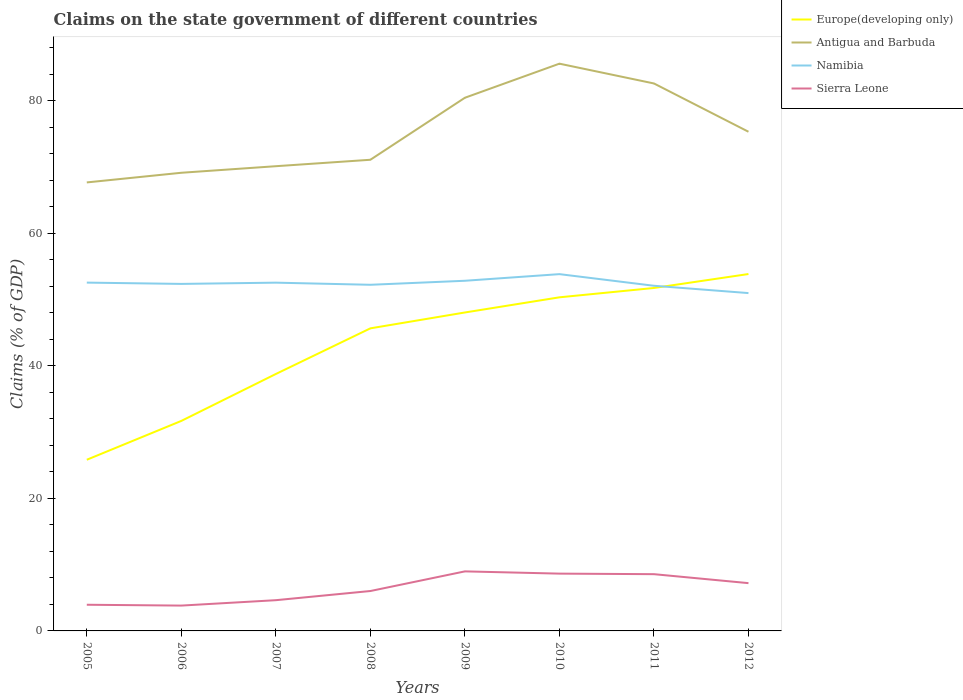Does the line corresponding to Europe(developing only) intersect with the line corresponding to Sierra Leone?
Keep it short and to the point. No. Across all years, what is the maximum percentage of GDP claimed on the state government in Europe(developing only)?
Your answer should be very brief. 25.82. In which year was the percentage of GDP claimed on the state government in Namibia maximum?
Provide a short and direct response. 2012. What is the total percentage of GDP claimed on the state government in Sierra Leone in the graph?
Ensure brevity in your answer.  -4.35. What is the difference between the highest and the second highest percentage of GDP claimed on the state government in Namibia?
Provide a short and direct response. 2.86. Is the percentage of GDP claimed on the state government in Sierra Leone strictly greater than the percentage of GDP claimed on the state government in Namibia over the years?
Your response must be concise. Yes. What is the difference between two consecutive major ticks on the Y-axis?
Give a very brief answer. 20. Are the values on the major ticks of Y-axis written in scientific E-notation?
Your response must be concise. No. Does the graph contain any zero values?
Your answer should be compact. No. Does the graph contain grids?
Make the answer very short. No. How many legend labels are there?
Provide a succinct answer. 4. What is the title of the graph?
Make the answer very short. Claims on the state government of different countries. Does "Hungary" appear as one of the legend labels in the graph?
Ensure brevity in your answer.  No. What is the label or title of the Y-axis?
Offer a terse response. Claims (% of GDP). What is the Claims (% of GDP) of Europe(developing only) in 2005?
Provide a succinct answer. 25.82. What is the Claims (% of GDP) in Antigua and Barbuda in 2005?
Your response must be concise. 67.66. What is the Claims (% of GDP) of Namibia in 2005?
Your answer should be compact. 52.55. What is the Claims (% of GDP) of Sierra Leone in 2005?
Provide a succinct answer. 3.95. What is the Claims (% of GDP) in Europe(developing only) in 2006?
Offer a terse response. 31.68. What is the Claims (% of GDP) in Antigua and Barbuda in 2006?
Make the answer very short. 69.12. What is the Claims (% of GDP) in Namibia in 2006?
Provide a succinct answer. 52.35. What is the Claims (% of GDP) in Sierra Leone in 2006?
Provide a succinct answer. 3.82. What is the Claims (% of GDP) of Europe(developing only) in 2007?
Ensure brevity in your answer.  38.76. What is the Claims (% of GDP) in Antigua and Barbuda in 2007?
Provide a succinct answer. 70.11. What is the Claims (% of GDP) in Namibia in 2007?
Make the answer very short. 52.54. What is the Claims (% of GDP) in Sierra Leone in 2007?
Make the answer very short. 4.64. What is the Claims (% of GDP) of Europe(developing only) in 2008?
Make the answer very short. 45.65. What is the Claims (% of GDP) of Antigua and Barbuda in 2008?
Your answer should be very brief. 71.08. What is the Claims (% of GDP) of Namibia in 2008?
Offer a very short reply. 52.22. What is the Claims (% of GDP) of Sierra Leone in 2008?
Provide a succinct answer. 6.02. What is the Claims (% of GDP) in Europe(developing only) in 2009?
Your answer should be compact. 48.04. What is the Claims (% of GDP) in Antigua and Barbuda in 2009?
Make the answer very short. 80.43. What is the Claims (% of GDP) of Namibia in 2009?
Offer a very short reply. 52.82. What is the Claims (% of GDP) in Sierra Leone in 2009?
Provide a succinct answer. 8.98. What is the Claims (% of GDP) in Europe(developing only) in 2010?
Offer a terse response. 50.33. What is the Claims (% of GDP) of Antigua and Barbuda in 2010?
Provide a short and direct response. 85.58. What is the Claims (% of GDP) in Namibia in 2010?
Provide a short and direct response. 53.82. What is the Claims (% of GDP) of Sierra Leone in 2010?
Your answer should be very brief. 8.64. What is the Claims (% of GDP) of Europe(developing only) in 2011?
Give a very brief answer. 51.74. What is the Claims (% of GDP) in Antigua and Barbuda in 2011?
Your answer should be compact. 82.59. What is the Claims (% of GDP) in Namibia in 2011?
Give a very brief answer. 52.07. What is the Claims (% of GDP) in Sierra Leone in 2011?
Give a very brief answer. 8.56. What is the Claims (% of GDP) of Europe(developing only) in 2012?
Give a very brief answer. 53.84. What is the Claims (% of GDP) of Antigua and Barbuda in 2012?
Your response must be concise. 75.3. What is the Claims (% of GDP) of Namibia in 2012?
Offer a very short reply. 50.97. What is the Claims (% of GDP) of Sierra Leone in 2012?
Offer a terse response. 7.21. Across all years, what is the maximum Claims (% of GDP) of Europe(developing only)?
Offer a terse response. 53.84. Across all years, what is the maximum Claims (% of GDP) in Antigua and Barbuda?
Your answer should be compact. 85.58. Across all years, what is the maximum Claims (% of GDP) of Namibia?
Your response must be concise. 53.82. Across all years, what is the maximum Claims (% of GDP) in Sierra Leone?
Offer a very short reply. 8.98. Across all years, what is the minimum Claims (% of GDP) of Europe(developing only)?
Your response must be concise. 25.82. Across all years, what is the minimum Claims (% of GDP) in Antigua and Barbuda?
Give a very brief answer. 67.66. Across all years, what is the minimum Claims (% of GDP) in Namibia?
Provide a succinct answer. 50.97. Across all years, what is the minimum Claims (% of GDP) of Sierra Leone?
Ensure brevity in your answer.  3.82. What is the total Claims (% of GDP) in Europe(developing only) in the graph?
Provide a short and direct response. 345.86. What is the total Claims (% of GDP) of Antigua and Barbuda in the graph?
Make the answer very short. 601.87. What is the total Claims (% of GDP) of Namibia in the graph?
Provide a succinct answer. 419.34. What is the total Claims (% of GDP) in Sierra Leone in the graph?
Offer a very short reply. 51.82. What is the difference between the Claims (% of GDP) of Europe(developing only) in 2005 and that in 2006?
Offer a very short reply. -5.86. What is the difference between the Claims (% of GDP) of Antigua and Barbuda in 2005 and that in 2006?
Offer a terse response. -1.46. What is the difference between the Claims (% of GDP) of Namibia in 2005 and that in 2006?
Keep it short and to the point. 0.2. What is the difference between the Claims (% of GDP) of Sierra Leone in 2005 and that in 2006?
Your response must be concise. 0.13. What is the difference between the Claims (% of GDP) in Europe(developing only) in 2005 and that in 2007?
Keep it short and to the point. -12.94. What is the difference between the Claims (% of GDP) of Antigua and Barbuda in 2005 and that in 2007?
Give a very brief answer. -2.45. What is the difference between the Claims (% of GDP) in Namibia in 2005 and that in 2007?
Keep it short and to the point. 0.01. What is the difference between the Claims (% of GDP) in Sierra Leone in 2005 and that in 2007?
Provide a short and direct response. -0.69. What is the difference between the Claims (% of GDP) of Europe(developing only) in 2005 and that in 2008?
Your response must be concise. -19.82. What is the difference between the Claims (% of GDP) in Antigua and Barbuda in 2005 and that in 2008?
Make the answer very short. -3.42. What is the difference between the Claims (% of GDP) of Namibia in 2005 and that in 2008?
Give a very brief answer. 0.33. What is the difference between the Claims (% of GDP) of Sierra Leone in 2005 and that in 2008?
Your response must be concise. -2.07. What is the difference between the Claims (% of GDP) of Europe(developing only) in 2005 and that in 2009?
Provide a short and direct response. -22.22. What is the difference between the Claims (% of GDP) in Antigua and Barbuda in 2005 and that in 2009?
Your answer should be very brief. -12.77. What is the difference between the Claims (% of GDP) in Namibia in 2005 and that in 2009?
Provide a succinct answer. -0.28. What is the difference between the Claims (% of GDP) in Sierra Leone in 2005 and that in 2009?
Provide a succinct answer. -5.04. What is the difference between the Claims (% of GDP) of Europe(developing only) in 2005 and that in 2010?
Offer a terse response. -24.5. What is the difference between the Claims (% of GDP) in Antigua and Barbuda in 2005 and that in 2010?
Offer a very short reply. -17.91. What is the difference between the Claims (% of GDP) in Namibia in 2005 and that in 2010?
Your response must be concise. -1.28. What is the difference between the Claims (% of GDP) of Sierra Leone in 2005 and that in 2010?
Provide a short and direct response. -4.7. What is the difference between the Claims (% of GDP) of Europe(developing only) in 2005 and that in 2011?
Provide a short and direct response. -25.91. What is the difference between the Claims (% of GDP) in Antigua and Barbuda in 2005 and that in 2011?
Offer a very short reply. -14.93. What is the difference between the Claims (% of GDP) in Namibia in 2005 and that in 2011?
Offer a very short reply. 0.48. What is the difference between the Claims (% of GDP) of Sierra Leone in 2005 and that in 2011?
Give a very brief answer. -4.61. What is the difference between the Claims (% of GDP) of Europe(developing only) in 2005 and that in 2012?
Ensure brevity in your answer.  -28.02. What is the difference between the Claims (% of GDP) of Antigua and Barbuda in 2005 and that in 2012?
Keep it short and to the point. -7.64. What is the difference between the Claims (% of GDP) in Namibia in 2005 and that in 2012?
Provide a short and direct response. 1.58. What is the difference between the Claims (% of GDP) of Sierra Leone in 2005 and that in 2012?
Offer a very short reply. -3.26. What is the difference between the Claims (% of GDP) in Europe(developing only) in 2006 and that in 2007?
Provide a succinct answer. -7.08. What is the difference between the Claims (% of GDP) in Antigua and Barbuda in 2006 and that in 2007?
Offer a terse response. -0.99. What is the difference between the Claims (% of GDP) of Namibia in 2006 and that in 2007?
Provide a short and direct response. -0.19. What is the difference between the Claims (% of GDP) in Sierra Leone in 2006 and that in 2007?
Give a very brief answer. -0.81. What is the difference between the Claims (% of GDP) in Europe(developing only) in 2006 and that in 2008?
Give a very brief answer. -13.96. What is the difference between the Claims (% of GDP) of Antigua and Barbuda in 2006 and that in 2008?
Give a very brief answer. -1.96. What is the difference between the Claims (% of GDP) in Namibia in 2006 and that in 2008?
Offer a very short reply. 0.13. What is the difference between the Claims (% of GDP) in Sierra Leone in 2006 and that in 2008?
Ensure brevity in your answer.  -2.2. What is the difference between the Claims (% of GDP) in Europe(developing only) in 2006 and that in 2009?
Make the answer very short. -16.36. What is the difference between the Claims (% of GDP) of Antigua and Barbuda in 2006 and that in 2009?
Give a very brief answer. -11.32. What is the difference between the Claims (% of GDP) in Namibia in 2006 and that in 2009?
Ensure brevity in your answer.  -0.47. What is the difference between the Claims (% of GDP) in Sierra Leone in 2006 and that in 2009?
Ensure brevity in your answer.  -5.16. What is the difference between the Claims (% of GDP) in Europe(developing only) in 2006 and that in 2010?
Provide a succinct answer. -18.65. What is the difference between the Claims (% of GDP) of Antigua and Barbuda in 2006 and that in 2010?
Make the answer very short. -16.46. What is the difference between the Claims (% of GDP) in Namibia in 2006 and that in 2010?
Keep it short and to the point. -1.47. What is the difference between the Claims (% of GDP) in Sierra Leone in 2006 and that in 2010?
Offer a terse response. -4.82. What is the difference between the Claims (% of GDP) in Europe(developing only) in 2006 and that in 2011?
Your response must be concise. -20.06. What is the difference between the Claims (% of GDP) of Antigua and Barbuda in 2006 and that in 2011?
Keep it short and to the point. -13.47. What is the difference between the Claims (% of GDP) in Namibia in 2006 and that in 2011?
Provide a short and direct response. 0.28. What is the difference between the Claims (% of GDP) of Sierra Leone in 2006 and that in 2011?
Keep it short and to the point. -4.74. What is the difference between the Claims (% of GDP) of Europe(developing only) in 2006 and that in 2012?
Offer a very short reply. -22.16. What is the difference between the Claims (% of GDP) of Antigua and Barbuda in 2006 and that in 2012?
Your answer should be compact. -6.19. What is the difference between the Claims (% of GDP) in Namibia in 2006 and that in 2012?
Ensure brevity in your answer.  1.38. What is the difference between the Claims (% of GDP) in Sierra Leone in 2006 and that in 2012?
Provide a short and direct response. -3.39. What is the difference between the Claims (% of GDP) of Europe(developing only) in 2007 and that in 2008?
Ensure brevity in your answer.  -6.89. What is the difference between the Claims (% of GDP) of Antigua and Barbuda in 2007 and that in 2008?
Your answer should be very brief. -0.97. What is the difference between the Claims (% of GDP) of Namibia in 2007 and that in 2008?
Offer a terse response. 0.32. What is the difference between the Claims (% of GDP) in Sierra Leone in 2007 and that in 2008?
Offer a very short reply. -1.38. What is the difference between the Claims (% of GDP) in Europe(developing only) in 2007 and that in 2009?
Ensure brevity in your answer.  -9.28. What is the difference between the Claims (% of GDP) in Antigua and Barbuda in 2007 and that in 2009?
Make the answer very short. -10.33. What is the difference between the Claims (% of GDP) in Namibia in 2007 and that in 2009?
Provide a short and direct response. -0.28. What is the difference between the Claims (% of GDP) in Sierra Leone in 2007 and that in 2009?
Your response must be concise. -4.35. What is the difference between the Claims (% of GDP) of Europe(developing only) in 2007 and that in 2010?
Provide a succinct answer. -11.57. What is the difference between the Claims (% of GDP) in Antigua and Barbuda in 2007 and that in 2010?
Your response must be concise. -15.47. What is the difference between the Claims (% of GDP) of Namibia in 2007 and that in 2010?
Your answer should be very brief. -1.28. What is the difference between the Claims (% of GDP) in Sierra Leone in 2007 and that in 2010?
Make the answer very short. -4.01. What is the difference between the Claims (% of GDP) of Europe(developing only) in 2007 and that in 2011?
Give a very brief answer. -12.98. What is the difference between the Claims (% of GDP) in Antigua and Barbuda in 2007 and that in 2011?
Offer a very short reply. -12.48. What is the difference between the Claims (% of GDP) in Namibia in 2007 and that in 2011?
Ensure brevity in your answer.  0.47. What is the difference between the Claims (% of GDP) of Sierra Leone in 2007 and that in 2011?
Provide a succinct answer. -3.92. What is the difference between the Claims (% of GDP) of Europe(developing only) in 2007 and that in 2012?
Ensure brevity in your answer.  -15.08. What is the difference between the Claims (% of GDP) of Antigua and Barbuda in 2007 and that in 2012?
Keep it short and to the point. -5.2. What is the difference between the Claims (% of GDP) in Namibia in 2007 and that in 2012?
Keep it short and to the point. 1.57. What is the difference between the Claims (% of GDP) in Sierra Leone in 2007 and that in 2012?
Ensure brevity in your answer.  -2.57. What is the difference between the Claims (% of GDP) in Europe(developing only) in 2008 and that in 2009?
Give a very brief answer. -2.39. What is the difference between the Claims (% of GDP) of Antigua and Barbuda in 2008 and that in 2009?
Keep it short and to the point. -9.35. What is the difference between the Claims (% of GDP) in Namibia in 2008 and that in 2009?
Make the answer very short. -0.6. What is the difference between the Claims (% of GDP) of Sierra Leone in 2008 and that in 2009?
Provide a succinct answer. -2.96. What is the difference between the Claims (% of GDP) in Europe(developing only) in 2008 and that in 2010?
Give a very brief answer. -4.68. What is the difference between the Claims (% of GDP) of Antigua and Barbuda in 2008 and that in 2010?
Offer a terse response. -14.5. What is the difference between the Claims (% of GDP) in Namibia in 2008 and that in 2010?
Your answer should be very brief. -1.6. What is the difference between the Claims (% of GDP) of Sierra Leone in 2008 and that in 2010?
Your response must be concise. -2.62. What is the difference between the Claims (% of GDP) of Europe(developing only) in 2008 and that in 2011?
Provide a succinct answer. -6.09. What is the difference between the Claims (% of GDP) of Antigua and Barbuda in 2008 and that in 2011?
Provide a succinct answer. -11.51. What is the difference between the Claims (% of GDP) in Namibia in 2008 and that in 2011?
Make the answer very short. 0.15. What is the difference between the Claims (% of GDP) of Sierra Leone in 2008 and that in 2011?
Provide a succinct answer. -2.54. What is the difference between the Claims (% of GDP) in Europe(developing only) in 2008 and that in 2012?
Your answer should be very brief. -8.19. What is the difference between the Claims (% of GDP) of Antigua and Barbuda in 2008 and that in 2012?
Your answer should be compact. -4.23. What is the difference between the Claims (% of GDP) in Namibia in 2008 and that in 2012?
Offer a very short reply. 1.25. What is the difference between the Claims (% of GDP) in Sierra Leone in 2008 and that in 2012?
Provide a short and direct response. -1.19. What is the difference between the Claims (% of GDP) of Europe(developing only) in 2009 and that in 2010?
Provide a short and direct response. -2.29. What is the difference between the Claims (% of GDP) of Antigua and Barbuda in 2009 and that in 2010?
Keep it short and to the point. -5.14. What is the difference between the Claims (% of GDP) in Namibia in 2009 and that in 2010?
Your response must be concise. -1. What is the difference between the Claims (% of GDP) in Sierra Leone in 2009 and that in 2010?
Provide a succinct answer. 0.34. What is the difference between the Claims (% of GDP) of Europe(developing only) in 2009 and that in 2011?
Provide a succinct answer. -3.7. What is the difference between the Claims (% of GDP) in Antigua and Barbuda in 2009 and that in 2011?
Provide a succinct answer. -2.16. What is the difference between the Claims (% of GDP) of Namibia in 2009 and that in 2011?
Your answer should be compact. 0.75. What is the difference between the Claims (% of GDP) in Sierra Leone in 2009 and that in 2011?
Provide a succinct answer. 0.42. What is the difference between the Claims (% of GDP) in Europe(developing only) in 2009 and that in 2012?
Provide a short and direct response. -5.8. What is the difference between the Claims (% of GDP) in Antigua and Barbuda in 2009 and that in 2012?
Offer a very short reply. 5.13. What is the difference between the Claims (% of GDP) in Namibia in 2009 and that in 2012?
Provide a short and direct response. 1.86. What is the difference between the Claims (% of GDP) of Sierra Leone in 2009 and that in 2012?
Make the answer very short. 1.77. What is the difference between the Claims (% of GDP) of Europe(developing only) in 2010 and that in 2011?
Offer a very short reply. -1.41. What is the difference between the Claims (% of GDP) in Antigua and Barbuda in 2010 and that in 2011?
Your answer should be very brief. 2.99. What is the difference between the Claims (% of GDP) of Namibia in 2010 and that in 2011?
Make the answer very short. 1.75. What is the difference between the Claims (% of GDP) of Sierra Leone in 2010 and that in 2011?
Keep it short and to the point. 0.08. What is the difference between the Claims (% of GDP) in Europe(developing only) in 2010 and that in 2012?
Offer a very short reply. -3.51. What is the difference between the Claims (% of GDP) of Antigua and Barbuda in 2010 and that in 2012?
Provide a succinct answer. 10.27. What is the difference between the Claims (% of GDP) in Namibia in 2010 and that in 2012?
Offer a terse response. 2.86. What is the difference between the Claims (% of GDP) of Sierra Leone in 2010 and that in 2012?
Your answer should be compact. 1.44. What is the difference between the Claims (% of GDP) in Europe(developing only) in 2011 and that in 2012?
Provide a short and direct response. -2.1. What is the difference between the Claims (% of GDP) in Antigua and Barbuda in 2011 and that in 2012?
Your response must be concise. 7.29. What is the difference between the Claims (% of GDP) of Namibia in 2011 and that in 2012?
Give a very brief answer. 1.1. What is the difference between the Claims (% of GDP) in Sierra Leone in 2011 and that in 2012?
Your response must be concise. 1.35. What is the difference between the Claims (% of GDP) of Europe(developing only) in 2005 and the Claims (% of GDP) of Antigua and Barbuda in 2006?
Offer a very short reply. -43.29. What is the difference between the Claims (% of GDP) in Europe(developing only) in 2005 and the Claims (% of GDP) in Namibia in 2006?
Your answer should be very brief. -26.53. What is the difference between the Claims (% of GDP) in Europe(developing only) in 2005 and the Claims (% of GDP) in Sierra Leone in 2006?
Offer a very short reply. 22. What is the difference between the Claims (% of GDP) in Antigua and Barbuda in 2005 and the Claims (% of GDP) in Namibia in 2006?
Your answer should be compact. 15.31. What is the difference between the Claims (% of GDP) of Antigua and Barbuda in 2005 and the Claims (% of GDP) of Sierra Leone in 2006?
Make the answer very short. 63.84. What is the difference between the Claims (% of GDP) of Namibia in 2005 and the Claims (% of GDP) of Sierra Leone in 2006?
Offer a very short reply. 48.72. What is the difference between the Claims (% of GDP) in Europe(developing only) in 2005 and the Claims (% of GDP) in Antigua and Barbuda in 2007?
Your answer should be very brief. -44.28. What is the difference between the Claims (% of GDP) of Europe(developing only) in 2005 and the Claims (% of GDP) of Namibia in 2007?
Your answer should be very brief. -26.72. What is the difference between the Claims (% of GDP) of Europe(developing only) in 2005 and the Claims (% of GDP) of Sierra Leone in 2007?
Your response must be concise. 21.19. What is the difference between the Claims (% of GDP) in Antigua and Barbuda in 2005 and the Claims (% of GDP) in Namibia in 2007?
Your answer should be compact. 15.12. What is the difference between the Claims (% of GDP) of Antigua and Barbuda in 2005 and the Claims (% of GDP) of Sierra Leone in 2007?
Your response must be concise. 63.03. What is the difference between the Claims (% of GDP) of Namibia in 2005 and the Claims (% of GDP) of Sierra Leone in 2007?
Provide a short and direct response. 47.91. What is the difference between the Claims (% of GDP) of Europe(developing only) in 2005 and the Claims (% of GDP) of Antigua and Barbuda in 2008?
Provide a succinct answer. -45.26. What is the difference between the Claims (% of GDP) in Europe(developing only) in 2005 and the Claims (% of GDP) in Namibia in 2008?
Provide a short and direct response. -26.4. What is the difference between the Claims (% of GDP) of Europe(developing only) in 2005 and the Claims (% of GDP) of Sierra Leone in 2008?
Ensure brevity in your answer.  19.8. What is the difference between the Claims (% of GDP) of Antigua and Barbuda in 2005 and the Claims (% of GDP) of Namibia in 2008?
Offer a terse response. 15.44. What is the difference between the Claims (% of GDP) of Antigua and Barbuda in 2005 and the Claims (% of GDP) of Sierra Leone in 2008?
Your response must be concise. 61.64. What is the difference between the Claims (% of GDP) of Namibia in 2005 and the Claims (% of GDP) of Sierra Leone in 2008?
Your answer should be very brief. 46.53. What is the difference between the Claims (% of GDP) in Europe(developing only) in 2005 and the Claims (% of GDP) in Antigua and Barbuda in 2009?
Offer a terse response. -54.61. What is the difference between the Claims (% of GDP) in Europe(developing only) in 2005 and the Claims (% of GDP) in Namibia in 2009?
Ensure brevity in your answer.  -27. What is the difference between the Claims (% of GDP) in Europe(developing only) in 2005 and the Claims (% of GDP) in Sierra Leone in 2009?
Offer a very short reply. 16.84. What is the difference between the Claims (% of GDP) in Antigua and Barbuda in 2005 and the Claims (% of GDP) in Namibia in 2009?
Your response must be concise. 14.84. What is the difference between the Claims (% of GDP) of Antigua and Barbuda in 2005 and the Claims (% of GDP) of Sierra Leone in 2009?
Your answer should be very brief. 58.68. What is the difference between the Claims (% of GDP) of Namibia in 2005 and the Claims (% of GDP) of Sierra Leone in 2009?
Ensure brevity in your answer.  43.56. What is the difference between the Claims (% of GDP) of Europe(developing only) in 2005 and the Claims (% of GDP) of Antigua and Barbuda in 2010?
Make the answer very short. -59.75. What is the difference between the Claims (% of GDP) of Europe(developing only) in 2005 and the Claims (% of GDP) of Namibia in 2010?
Your answer should be compact. -28. What is the difference between the Claims (% of GDP) of Europe(developing only) in 2005 and the Claims (% of GDP) of Sierra Leone in 2010?
Offer a terse response. 17.18. What is the difference between the Claims (% of GDP) of Antigua and Barbuda in 2005 and the Claims (% of GDP) of Namibia in 2010?
Provide a short and direct response. 13.84. What is the difference between the Claims (% of GDP) of Antigua and Barbuda in 2005 and the Claims (% of GDP) of Sierra Leone in 2010?
Give a very brief answer. 59.02. What is the difference between the Claims (% of GDP) in Namibia in 2005 and the Claims (% of GDP) in Sierra Leone in 2010?
Keep it short and to the point. 43.9. What is the difference between the Claims (% of GDP) in Europe(developing only) in 2005 and the Claims (% of GDP) in Antigua and Barbuda in 2011?
Keep it short and to the point. -56.77. What is the difference between the Claims (% of GDP) in Europe(developing only) in 2005 and the Claims (% of GDP) in Namibia in 2011?
Keep it short and to the point. -26.25. What is the difference between the Claims (% of GDP) in Europe(developing only) in 2005 and the Claims (% of GDP) in Sierra Leone in 2011?
Give a very brief answer. 17.26. What is the difference between the Claims (% of GDP) of Antigua and Barbuda in 2005 and the Claims (% of GDP) of Namibia in 2011?
Make the answer very short. 15.59. What is the difference between the Claims (% of GDP) in Antigua and Barbuda in 2005 and the Claims (% of GDP) in Sierra Leone in 2011?
Your answer should be very brief. 59.1. What is the difference between the Claims (% of GDP) of Namibia in 2005 and the Claims (% of GDP) of Sierra Leone in 2011?
Provide a short and direct response. 43.99. What is the difference between the Claims (% of GDP) in Europe(developing only) in 2005 and the Claims (% of GDP) in Antigua and Barbuda in 2012?
Provide a short and direct response. -49.48. What is the difference between the Claims (% of GDP) in Europe(developing only) in 2005 and the Claims (% of GDP) in Namibia in 2012?
Offer a very short reply. -25.14. What is the difference between the Claims (% of GDP) of Europe(developing only) in 2005 and the Claims (% of GDP) of Sierra Leone in 2012?
Provide a succinct answer. 18.62. What is the difference between the Claims (% of GDP) of Antigua and Barbuda in 2005 and the Claims (% of GDP) of Namibia in 2012?
Provide a succinct answer. 16.7. What is the difference between the Claims (% of GDP) in Antigua and Barbuda in 2005 and the Claims (% of GDP) in Sierra Leone in 2012?
Provide a succinct answer. 60.45. What is the difference between the Claims (% of GDP) of Namibia in 2005 and the Claims (% of GDP) of Sierra Leone in 2012?
Your answer should be very brief. 45.34. What is the difference between the Claims (% of GDP) of Europe(developing only) in 2006 and the Claims (% of GDP) of Antigua and Barbuda in 2007?
Provide a short and direct response. -38.43. What is the difference between the Claims (% of GDP) of Europe(developing only) in 2006 and the Claims (% of GDP) of Namibia in 2007?
Ensure brevity in your answer.  -20.86. What is the difference between the Claims (% of GDP) in Europe(developing only) in 2006 and the Claims (% of GDP) in Sierra Leone in 2007?
Provide a succinct answer. 27.05. What is the difference between the Claims (% of GDP) of Antigua and Barbuda in 2006 and the Claims (% of GDP) of Namibia in 2007?
Offer a very short reply. 16.58. What is the difference between the Claims (% of GDP) of Antigua and Barbuda in 2006 and the Claims (% of GDP) of Sierra Leone in 2007?
Your answer should be very brief. 64.48. What is the difference between the Claims (% of GDP) in Namibia in 2006 and the Claims (% of GDP) in Sierra Leone in 2007?
Your response must be concise. 47.71. What is the difference between the Claims (% of GDP) in Europe(developing only) in 2006 and the Claims (% of GDP) in Antigua and Barbuda in 2008?
Provide a short and direct response. -39.4. What is the difference between the Claims (% of GDP) in Europe(developing only) in 2006 and the Claims (% of GDP) in Namibia in 2008?
Provide a succinct answer. -20.54. What is the difference between the Claims (% of GDP) of Europe(developing only) in 2006 and the Claims (% of GDP) of Sierra Leone in 2008?
Make the answer very short. 25.66. What is the difference between the Claims (% of GDP) of Antigua and Barbuda in 2006 and the Claims (% of GDP) of Namibia in 2008?
Ensure brevity in your answer.  16.9. What is the difference between the Claims (% of GDP) in Antigua and Barbuda in 2006 and the Claims (% of GDP) in Sierra Leone in 2008?
Make the answer very short. 63.1. What is the difference between the Claims (% of GDP) of Namibia in 2006 and the Claims (% of GDP) of Sierra Leone in 2008?
Your response must be concise. 46.33. What is the difference between the Claims (% of GDP) of Europe(developing only) in 2006 and the Claims (% of GDP) of Antigua and Barbuda in 2009?
Give a very brief answer. -48.75. What is the difference between the Claims (% of GDP) of Europe(developing only) in 2006 and the Claims (% of GDP) of Namibia in 2009?
Your answer should be compact. -21.14. What is the difference between the Claims (% of GDP) of Europe(developing only) in 2006 and the Claims (% of GDP) of Sierra Leone in 2009?
Offer a very short reply. 22.7. What is the difference between the Claims (% of GDP) of Antigua and Barbuda in 2006 and the Claims (% of GDP) of Namibia in 2009?
Give a very brief answer. 16.29. What is the difference between the Claims (% of GDP) of Antigua and Barbuda in 2006 and the Claims (% of GDP) of Sierra Leone in 2009?
Provide a succinct answer. 60.14. What is the difference between the Claims (% of GDP) of Namibia in 2006 and the Claims (% of GDP) of Sierra Leone in 2009?
Your answer should be compact. 43.37. What is the difference between the Claims (% of GDP) of Europe(developing only) in 2006 and the Claims (% of GDP) of Antigua and Barbuda in 2010?
Give a very brief answer. -53.89. What is the difference between the Claims (% of GDP) of Europe(developing only) in 2006 and the Claims (% of GDP) of Namibia in 2010?
Provide a succinct answer. -22.14. What is the difference between the Claims (% of GDP) in Europe(developing only) in 2006 and the Claims (% of GDP) in Sierra Leone in 2010?
Provide a succinct answer. 23.04. What is the difference between the Claims (% of GDP) of Antigua and Barbuda in 2006 and the Claims (% of GDP) of Namibia in 2010?
Keep it short and to the point. 15.29. What is the difference between the Claims (% of GDP) in Antigua and Barbuda in 2006 and the Claims (% of GDP) in Sierra Leone in 2010?
Make the answer very short. 60.47. What is the difference between the Claims (% of GDP) in Namibia in 2006 and the Claims (% of GDP) in Sierra Leone in 2010?
Make the answer very short. 43.71. What is the difference between the Claims (% of GDP) of Europe(developing only) in 2006 and the Claims (% of GDP) of Antigua and Barbuda in 2011?
Provide a succinct answer. -50.91. What is the difference between the Claims (% of GDP) in Europe(developing only) in 2006 and the Claims (% of GDP) in Namibia in 2011?
Your answer should be very brief. -20.39. What is the difference between the Claims (% of GDP) of Europe(developing only) in 2006 and the Claims (% of GDP) of Sierra Leone in 2011?
Ensure brevity in your answer.  23.12. What is the difference between the Claims (% of GDP) of Antigua and Barbuda in 2006 and the Claims (% of GDP) of Namibia in 2011?
Ensure brevity in your answer.  17.05. What is the difference between the Claims (% of GDP) in Antigua and Barbuda in 2006 and the Claims (% of GDP) in Sierra Leone in 2011?
Your response must be concise. 60.56. What is the difference between the Claims (% of GDP) in Namibia in 2006 and the Claims (% of GDP) in Sierra Leone in 2011?
Your response must be concise. 43.79. What is the difference between the Claims (% of GDP) in Europe(developing only) in 2006 and the Claims (% of GDP) in Antigua and Barbuda in 2012?
Offer a very short reply. -43.62. What is the difference between the Claims (% of GDP) of Europe(developing only) in 2006 and the Claims (% of GDP) of Namibia in 2012?
Keep it short and to the point. -19.28. What is the difference between the Claims (% of GDP) in Europe(developing only) in 2006 and the Claims (% of GDP) in Sierra Leone in 2012?
Ensure brevity in your answer.  24.47. What is the difference between the Claims (% of GDP) in Antigua and Barbuda in 2006 and the Claims (% of GDP) in Namibia in 2012?
Provide a succinct answer. 18.15. What is the difference between the Claims (% of GDP) in Antigua and Barbuda in 2006 and the Claims (% of GDP) in Sierra Leone in 2012?
Keep it short and to the point. 61.91. What is the difference between the Claims (% of GDP) of Namibia in 2006 and the Claims (% of GDP) of Sierra Leone in 2012?
Keep it short and to the point. 45.14. What is the difference between the Claims (% of GDP) in Europe(developing only) in 2007 and the Claims (% of GDP) in Antigua and Barbuda in 2008?
Your answer should be very brief. -32.32. What is the difference between the Claims (% of GDP) in Europe(developing only) in 2007 and the Claims (% of GDP) in Namibia in 2008?
Provide a short and direct response. -13.46. What is the difference between the Claims (% of GDP) in Europe(developing only) in 2007 and the Claims (% of GDP) in Sierra Leone in 2008?
Your answer should be compact. 32.74. What is the difference between the Claims (% of GDP) in Antigua and Barbuda in 2007 and the Claims (% of GDP) in Namibia in 2008?
Make the answer very short. 17.89. What is the difference between the Claims (% of GDP) of Antigua and Barbuda in 2007 and the Claims (% of GDP) of Sierra Leone in 2008?
Your answer should be very brief. 64.09. What is the difference between the Claims (% of GDP) of Namibia in 2007 and the Claims (% of GDP) of Sierra Leone in 2008?
Provide a short and direct response. 46.52. What is the difference between the Claims (% of GDP) of Europe(developing only) in 2007 and the Claims (% of GDP) of Antigua and Barbuda in 2009?
Offer a terse response. -41.67. What is the difference between the Claims (% of GDP) of Europe(developing only) in 2007 and the Claims (% of GDP) of Namibia in 2009?
Your response must be concise. -14.06. What is the difference between the Claims (% of GDP) in Europe(developing only) in 2007 and the Claims (% of GDP) in Sierra Leone in 2009?
Offer a terse response. 29.78. What is the difference between the Claims (% of GDP) of Antigua and Barbuda in 2007 and the Claims (% of GDP) of Namibia in 2009?
Provide a succinct answer. 17.28. What is the difference between the Claims (% of GDP) in Antigua and Barbuda in 2007 and the Claims (% of GDP) in Sierra Leone in 2009?
Give a very brief answer. 61.12. What is the difference between the Claims (% of GDP) in Namibia in 2007 and the Claims (% of GDP) in Sierra Leone in 2009?
Keep it short and to the point. 43.56. What is the difference between the Claims (% of GDP) of Europe(developing only) in 2007 and the Claims (% of GDP) of Antigua and Barbuda in 2010?
Your answer should be compact. -46.82. What is the difference between the Claims (% of GDP) of Europe(developing only) in 2007 and the Claims (% of GDP) of Namibia in 2010?
Give a very brief answer. -15.06. What is the difference between the Claims (% of GDP) in Europe(developing only) in 2007 and the Claims (% of GDP) in Sierra Leone in 2010?
Provide a short and direct response. 30.12. What is the difference between the Claims (% of GDP) of Antigua and Barbuda in 2007 and the Claims (% of GDP) of Namibia in 2010?
Your answer should be compact. 16.28. What is the difference between the Claims (% of GDP) of Antigua and Barbuda in 2007 and the Claims (% of GDP) of Sierra Leone in 2010?
Your answer should be compact. 61.46. What is the difference between the Claims (% of GDP) of Namibia in 2007 and the Claims (% of GDP) of Sierra Leone in 2010?
Your answer should be compact. 43.9. What is the difference between the Claims (% of GDP) in Europe(developing only) in 2007 and the Claims (% of GDP) in Antigua and Barbuda in 2011?
Your answer should be compact. -43.83. What is the difference between the Claims (% of GDP) of Europe(developing only) in 2007 and the Claims (% of GDP) of Namibia in 2011?
Give a very brief answer. -13.31. What is the difference between the Claims (% of GDP) in Europe(developing only) in 2007 and the Claims (% of GDP) in Sierra Leone in 2011?
Offer a terse response. 30.2. What is the difference between the Claims (% of GDP) in Antigua and Barbuda in 2007 and the Claims (% of GDP) in Namibia in 2011?
Provide a short and direct response. 18.04. What is the difference between the Claims (% of GDP) of Antigua and Barbuda in 2007 and the Claims (% of GDP) of Sierra Leone in 2011?
Your response must be concise. 61.55. What is the difference between the Claims (% of GDP) in Namibia in 2007 and the Claims (% of GDP) in Sierra Leone in 2011?
Your answer should be very brief. 43.98. What is the difference between the Claims (% of GDP) in Europe(developing only) in 2007 and the Claims (% of GDP) in Antigua and Barbuda in 2012?
Provide a succinct answer. -36.54. What is the difference between the Claims (% of GDP) of Europe(developing only) in 2007 and the Claims (% of GDP) of Namibia in 2012?
Provide a short and direct response. -12.21. What is the difference between the Claims (% of GDP) of Europe(developing only) in 2007 and the Claims (% of GDP) of Sierra Leone in 2012?
Keep it short and to the point. 31.55. What is the difference between the Claims (% of GDP) in Antigua and Barbuda in 2007 and the Claims (% of GDP) in Namibia in 2012?
Keep it short and to the point. 19.14. What is the difference between the Claims (% of GDP) in Antigua and Barbuda in 2007 and the Claims (% of GDP) in Sierra Leone in 2012?
Your answer should be compact. 62.9. What is the difference between the Claims (% of GDP) of Namibia in 2007 and the Claims (% of GDP) of Sierra Leone in 2012?
Your answer should be very brief. 45.33. What is the difference between the Claims (% of GDP) of Europe(developing only) in 2008 and the Claims (% of GDP) of Antigua and Barbuda in 2009?
Give a very brief answer. -34.79. What is the difference between the Claims (% of GDP) of Europe(developing only) in 2008 and the Claims (% of GDP) of Namibia in 2009?
Offer a terse response. -7.18. What is the difference between the Claims (% of GDP) in Europe(developing only) in 2008 and the Claims (% of GDP) in Sierra Leone in 2009?
Your response must be concise. 36.66. What is the difference between the Claims (% of GDP) of Antigua and Barbuda in 2008 and the Claims (% of GDP) of Namibia in 2009?
Your response must be concise. 18.25. What is the difference between the Claims (% of GDP) of Antigua and Barbuda in 2008 and the Claims (% of GDP) of Sierra Leone in 2009?
Provide a succinct answer. 62.1. What is the difference between the Claims (% of GDP) in Namibia in 2008 and the Claims (% of GDP) in Sierra Leone in 2009?
Provide a short and direct response. 43.24. What is the difference between the Claims (% of GDP) of Europe(developing only) in 2008 and the Claims (% of GDP) of Antigua and Barbuda in 2010?
Provide a short and direct response. -39.93. What is the difference between the Claims (% of GDP) in Europe(developing only) in 2008 and the Claims (% of GDP) in Namibia in 2010?
Make the answer very short. -8.18. What is the difference between the Claims (% of GDP) of Europe(developing only) in 2008 and the Claims (% of GDP) of Sierra Leone in 2010?
Your answer should be compact. 37. What is the difference between the Claims (% of GDP) in Antigua and Barbuda in 2008 and the Claims (% of GDP) in Namibia in 2010?
Provide a short and direct response. 17.25. What is the difference between the Claims (% of GDP) of Antigua and Barbuda in 2008 and the Claims (% of GDP) of Sierra Leone in 2010?
Provide a succinct answer. 62.44. What is the difference between the Claims (% of GDP) of Namibia in 2008 and the Claims (% of GDP) of Sierra Leone in 2010?
Offer a terse response. 43.58. What is the difference between the Claims (% of GDP) of Europe(developing only) in 2008 and the Claims (% of GDP) of Antigua and Barbuda in 2011?
Your answer should be very brief. -36.94. What is the difference between the Claims (% of GDP) in Europe(developing only) in 2008 and the Claims (% of GDP) in Namibia in 2011?
Give a very brief answer. -6.42. What is the difference between the Claims (% of GDP) of Europe(developing only) in 2008 and the Claims (% of GDP) of Sierra Leone in 2011?
Your answer should be compact. 37.09. What is the difference between the Claims (% of GDP) in Antigua and Barbuda in 2008 and the Claims (% of GDP) in Namibia in 2011?
Your answer should be compact. 19.01. What is the difference between the Claims (% of GDP) in Antigua and Barbuda in 2008 and the Claims (% of GDP) in Sierra Leone in 2011?
Keep it short and to the point. 62.52. What is the difference between the Claims (% of GDP) of Namibia in 2008 and the Claims (% of GDP) of Sierra Leone in 2011?
Offer a terse response. 43.66. What is the difference between the Claims (% of GDP) in Europe(developing only) in 2008 and the Claims (% of GDP) in Antigua and Barbuda in 2012?
Ensure brevity in your answer.  -29.66. What is the difference between the Claims (% of GDP) of Europe(developing only) in 2008 and the Claims (% of GDP) of Namibia in 2012?
Offer a very short reply. -5.32. What is the difference between the Claims (% of GDP) of Europe(developing only) in 2008 and the Claims (% of GDP) of Sierra Leone in 2012?
Keep it short and to the point. 38.44. What is the difference between the Claims (% of GDP) of Antigua and Barbuda in 2008 and the Claims (% of GDP) of Namibia in 2012?
Your response must be concise. 20.11. What is the difference between the Claims (% of GDP) of Antigua and Barbuda in 2008 and the Claims (% of GDP) of Sierra Leone in 2012?
Your answer should be compact. 63.87. What is the difference between the Claims (% of GDP) in Namibia in 2008 and the Claims (% of GDP) in Sierra Leone in 2012?
Keep it short and to the point. 45.01. What is the difference between the Claims (% of GDP) of Europe(developing only) in 2009 and the Claims (% of GDP) of Antigua and Barbuda in 2010?
Keep it short and to the point. -37.54. What is the difference between the Claims (% of GDP) of Europe(developing only) in 2009 and the Claims (% of GDP) of Namibia in 2010?
Offer a very short reply. -5.78. What is the difference between the Claims (% of GDP) in Europe(developing only) in 2009 and the Claims (% of GDP) in Sierra Leone in 2010?
Your response must be concise. 39.4. What is the difference between the Claims (% of GDP) of Antigua and Barbuda in 2009 and the Claims (% of GDP) of Namibia in 2010?
Provide a short and direct response. 26.61. What is the difference between the Claims (% of GDP) in Antigua and Barbuda in 2009 and the Claims (% of GDP) in Sierra Leone in 2010?
Give a very brief answer. 71.79. What is the difference between the Claims (% of GDP) in Namibia in 2009 and the Claims (% of GDP) in Sierra Leone in 2010?
Offer a terse response. 44.18. What is the difference between the Claims (% of GDP) in Europe(developing only) in 2009 and the Claims (% of GDP) in Antigua and Barbuda in 2011?
Give a very brief answer. -34.55. What is the difference between the Claims (% of GDP) in Europe(developing only) in 2009 and the Claims (% of GDP) in Namibia in 2011?
Your response must be concise. -4.03. What is the difference between the Claims (% of GDP) in Europe(developing only) in 2009 and the Claims (% of GDP) in Sierra Leone in 2011?
Your answer should be compact. 39.48. What is the difference between the Claims (% of GDP) in Antigua and Barbuda in 2009 and the Claims (% of GDP) in Namibia in 2011?
Keep it short and to the point. 28.36. What is the difference between the Claims (% of GDP) in Antigua and Barbuda in 2009 and the Claims (% of GDP) in Sierra Leone in 2011?
Make the answer very short. 71.87. What is the difference between the Claims (% of GDP) of Namibia in 2009 and the Claims (% of GDP) of Sierra Leone in 2011?
Keep it short and to the point. 44.26. What is the difference between the Claims (% of GDP) in Europe(developing only) in 2009 and the Claims (% of GDP) in Antigua and Barbuda in 2012?
Provide a succinct answer. -27.26. What is the difference between the Claims (% of GDP) of Europe(developing only) in 2009 and the Claims (% of GDP) of Namibia in 2012?
Your answer should be very brief. -2.93. What is the difference between the Claims (% of GDP) of Europe(developing only) in 2009 and the Claims (% of GDP) of Sierra Leone in 2012?
Give a very brief answer. 40.83. What is the difference between the Claims (% of GDP) in Antigua and Barbuda in 2009 and the Claims (% of GDP) in Namibia in 2012?
Ensure brevity in your answer.  29.47. What is the difference between the Claims (% of GDP) of Antigua and Barbuda in 2009 and the Claims (% of GDP) of Sierra Leone in 2012?
Ensure brevity in your answer.  73.23. What is the difference between the Claims (% of GDP) in Namibia in 2009 and the Claims (% of GDP) in Sierra Leone in 2012?
Give a very brief answer. 45.62. What is the difference between the Claims (% of GDP) of Europe(developing only) in 2010 and the Claims (% of GDP) of Antigua and Barbuda in 2011?
Offer a terse response. -32.26. What is the difference between the Claims (% of GDP) of Europe(developing only) in 2010 and the Claims (% of GDP) of Namibia in 2011?
Provide a succinct answer. -1.74. What is the difference between the Claims (% of GDP) of Europe(developing only) in 2010 and the Claims (% of GDP) of Sierra Leone in 2011?
Provide a succinct answer. 41.77. What is the difference between the Claims (% of GDP) in Antigua and Barbuda in 2010 and the Claims (% of GDP) in Namibia in 2011?
Your answer should be very brief. 33.51. What is the difference between the Claims (% of GDP) in Antigua and Barbuda in 2010 and the Claims (% of GDP) in Sierra Leone in 2011?
Offer a very short reply. 77.02. What is the difference between the Claims (% of GDP) in Namibia in 2010 and the Claims (% of GDP) in Sierra Leone in 2011?
Your response must be concise. 45.26. What is the difference between the Claims (% of GDP) of Europe(developing only) in 2010 and the Claims (% of GDP) of Antigua and Barbuda in 2012?
Provide a succinct answer. -24.98. What is the difference between the Claims (% of GDP) in Europe(developing only) in 2010 and the Claims (% of GDP) in Namibia in 2012?
Offer a very short reply. -0.64. What is the difference between the Claims (% of GDP) of Europe(developing only) in 2010 and the Claims (% of GDP) of Sierra Leone in 2012?
Provide a short and direct response. 43.12. What is the difference between the Claims (% of GDP) in Antigua and Barbuda in 2010 and the Claims (% of GDP) in Namibia in 2012?
Provide a short and direct response. 34.61. What is the difference between the Claims (% of GDP) of Antigua and Barbuda in 2010 and the Claims (% of GDP) of Sierra Leone in 2012?
Provide a succinct answer. 78.37. What is the difference between the Claims (% of GDP) of Namibia in 2010 and the Claims (% of GDP) of Sierra Leone in 2012?
Your answer should be very brief. 46.62. What is the difference between the Claims (% of GDP) in Europe(developing only) in 2011 and the Claims (% of GDP) in Antigua and Barbuda in 2012?
Provide a short and direct response. -23.57. What is the difference between the Claims (% of GDP) of Europe(developing only) in 2011 and the Claims (% of GDP) of Namibia in 2012?
Your answer should be compact. 0.77. What is the difference between the Claims (% of GDP) in Europe(developing only) in 2011 and the Claims (% of GDP) in Sierra Leone in 2012?
Provide a short and direct response. 44.53. What is the difference between the Claims (% of GDP) of Antigua and Barbuda in 2011 and the Claims (% of GDP) of Namibia in 2012?
Offer a very short reply. 31.62. What is the difference between the Claims (% of GDP) of Antigua and Barbuda in 2011 and the Claims (% of GDP) of Sierra Leone in 2012?
Your answer should be compact. 75.38. What is the difference between the Claims (% of GDP) of Namibia in 2011 and the Claims (% of GDP) of Sierra Leone in 2012?
Keep it short and to the point. 44.86. What is the average Claims (% of GDP) in Europe(developing only) per year?
Make the answer very short. 43.23. What is the average Claims (% of GDP) of Antigua and Barbuda per year?
Keep it short and to the point. 75.23. What is the average Claims (% of GDP) of Namibia per year?
Your response must be concise. 52.42. What is the average Claims (% of GDP) of Sierra Leone per year?
Give a very brief answer. 6.48. In the year 2005, what is the difference between the Claims (% of GDP) of Europe(developing only) and Claims (% of GDP) of Antigua and Barbuda?
Make the answer very short. -41.84. In the year 2005, what is the difference between the Claims (% of GDP) in Europe(developing only) and Claims (% of GDP) in Namibia?
Give a very brief answer. -26.72. In the year 2005, what is the difference between the Claims (% of GDP) of Europe(developing only) and Claims (% of GDP) of Sierra Leone?
Give a very brief answer. 21.88. In the year 2005, what is the difference between the Claims (% of GDP) of Antigua and Barbuda and Claims (% of GDP) of Namibia?
Your answer should be very brief. 15.12. In the year 2005, what is the difference between the Claims (% of GDP) of Antigua and Barbuda and Claims (% of GDP) of Sierra Leone?
Make the answer very short. 63.71. In the year 2005, what is the difference between the Claims (% of GDP) of Namibia and Claims (% of GDP) of Sierra Leone?
Offer a terse response. 48.6. In the year 2006, what is the difference between the Claims (% of GDP) in Europe(developing only) and Claims (% of GDP) in Antigua and Barbuda?
Offer a very short reply. -37.44. In the year 2006, what is the difference between the Claims (% of GDP) in Europe(developing only) and Claims (% of GDP) in Namibia?
Your answer should be very brief. -20.67. In the year 2006, what is the difference between the Claims (% of GDP) of Europe(developing only) and Claims (% of GDP) of Sierra Leone?
Provide a short and direct response. 27.86. In the year 2006, what is the difference between the Claims (% of GDP) of Antigua and Barbuda and Claims (% of GDP) of Namibia?
Make the answer very short. 16.77. In the year 2006, what is the difference between the Claims (% of GDP) of Antigua and Barbuda and Claims (% of GDP) of Sierra Leone?
Offer a very short reply. 65.3. In the year 2006, what is the difference between the Claims (% of GDP) of Namibia and Claims (% of GDP) of Sierra Leone?
Keep it short and to the point. 48.53. In the year 2007, what is the difference between the Claims (% of GDP) of Europe(developing only) and Claims (% of GDP) of Antigua and Barbuda?
Offer a terse response. -31.35. In the year 2007, what is the difference between the Claims (% of GDP) in Europe(developing only) and Claims (% of GDP) in Namibia?
Give a very brief answer. -13.78. In the year 2007, what is the difference between the Claims (% of GDP) in Europe(developing only) and Claims (% of GDP) in Sierra Leone?
Provide a succinct answer. 34.12. In the year 2007, what is the difference between the Claims (% of GDP) of Antigua and Barbuda and Claims (% of GDP) of Namibia?
Your response must be concise. 17.57. In the year 2007, what is the difference between the Claims (% of GDP) in Antigua and Barbuda and Claims (% of GDP) in Sierra Leone?
Offer a very short reply. 65.47. In the year 2007, what is the difference between the Claims (% of GDP) of Namibia and Claims (% of GDP) of Sierra Leone?
Provide a succinct answer. 47.9. In the year 2008, what is the difference between the Claims (% of GDP) of Europe(developing only) and Claims (% of GDP) of Antigua and Barbuda?
Your answer should be compact. -25.43. In the year 2008, what is the difference between the Claims (% of GDP) in Europe(developing only) and Claims (% of GDP) in Namibia?
Your response must be concise. -6.57. In the year 2008, what is the difference between the Claims (% of GDP) of Europe(developing only) and Claims (% of GDP) of Sierra Leone?
Your answer should be compact. 39.63. In the year 2008, what is the difference between the Claims (% of GDP) in Antigua and Barbuda and Claims (% of GDP) in Namibia?
Give a very brief answer. 18.86. In the year 2008, what is the difference between the Claims (% of GDP) in Antigua and Barbuda and Claims (% of GDP) in Sierra Leone?
Ensure brevity in your answer.  65.06. In the year 2008, what is the difference between the Claims (% of GDP) in Namibia and Claims (% of GDP) in Sierra Leone?
Offer a very short reply. 46.2. In the year 2009, what is the difference between the Claims (% of GDP) of Europe(developing only) and Claims (% of GDP) of Antigua and Barbuda?
Offer a very short reply. -32.39. In the year 2009, what is the difference between the Claims (% of GDP) in Europe(developing only) and Claims (% of GDP) in Namibia?
Provide a succinct answer. -4.78. In the year 2009, what is the difference between the Claims (% of GDP) in Europe(developing only) and Claims (% of GDP) in Sierra Leone?
Ensure brevity in your answer.  39.06. In the year 2009, what is the difference between the Claims (% of GDP) of Antigua and Barbuda and Claims (% of GDP) of Namibia?
Your answer should be compact. 27.61. In the year 2009, what is the difference between the Claims (% of GDP) of Antigua and Barbuda and Claims (% of GDP) of Sierra Leone?
Provide a succinct answer. 71.45. In the year 2009, what is the difference between the Claims (% of GDP) in Namibia and Claims (% of GDP) in Sierra Leone?
Your answer should be compact. 43.84. In the year 2010, what is the difference between the Claims (% of GDP) in Europe(developing only) and Claims (% of GDP) in Antigua and Barbuda?
Make the answer very short. -35.25. In the year 2010, what is the difference between the Claims (% of GDP) in Europe(developing only) and Claims (% of GDP) in Namibia?
Your answer should be very brief. -3.5. In the year 2010, what is the difference between the Claims (% of GDP) in Europe(developing only) and Claims (% of GDP) in Sierra Leone?
Offer a very short reply. 41.68. In the year 2010, what is the difference between the Claims (% of GDP) in Antigua and Barbuda and Claims (% of GDP) in Namibia?
Your answer should be very brief. 31.75. In the year 2010, what is the difference between the Claims (% of GDP) of Antigua and Barbuda and Claims (% of GDP) of Sierra Leone?
Your answer should be very brief. 76.93. In the year 2010, what is the difference between the Claims (% of GDP) of Namibia and Claims (% of GDP) of Sierra Leone?
Offer a very short reply. 45.18. In the year 2011, what is the difference between the Claims (% of GDP) of Europe(developing only) and Claims (% of GDP) of Antigua and Barbuda?
Your answer should be compact. -30.85. In the year 2011, what is the difference between the Claims (% of GDP) in Europe(developing only) and Claims (% of GDP) in Namibia?
Give a very brief answer. -0.33. In the year 2011, what is the difference between the Claims (% of GDP) of Europe(developing only) and Claims (% of GDP) of Sierra Leone?
Provide a succinct answer. 43.18. In the year 2011, what is the difference between the Claims (% of GDP) in Antigua and Barbuda and Claims (% of GDP) in Namibia?
Offer a terse response. 30.52. In the year 2011, what is the difference between the Claims (% of GDP) of Antigua and Barbuda and Claims (% of GDP) of Sierra Leone?
Your answer should be very brief. 74.03. In the year 2011, what is the difference between the Claims (% of GDP) of Namibia and Claims (% of GDP) of Sierra Leone?
Give a very brief answer. 43.51. In the year 2012, what is the difference between the Claims (% of GDP) in Europe(developing only) and Claims (% of GDP) in Antigua and Barbuda?
Your answer should be very brief. -21.46. In the year 2012, what is the difference between the Claims (% of GDP) in Europe(developing only) and Claims (% of GDP) in Namibia?
Your answer should be very brief. 2.87. In the year 2012, what is the difference between the Claims (% of GDP) in Europe(developing only) and Claims (% of GDP) in Sierra Leone?
Keep it short and to the point. 46.63. In the year 2012, what is the difference between the Claims (% of GDP) of Antigua and Barbuda and Claims (% of GDP) of Namibia?
Your response must be concise. 24.34. In the year 2012, what is the difference between the Claims (% of GDP) of Antigua and Barbuda and Claims (% of GDP) of Sierra Leone?
Make the answer very short. 68.1. In the year 2012, what is the difference between the Claims (% of GDP) in Namibia and Claims (% of GDP) in Sierra Leone?
Your answer should be compact. 43.76. What is the ratio of the Claims (% of GDP) of Europe(developing only) in 2005 to that in 2006?
Your response must be concise. 0.82. What is the ratio of the Claims (% of GDP) in Antigua and Barbuda in 2005 to that in 2006?
Ensure brevity in your answer.  0.98. What is the ratio of the Claims (% of GDP) of Namibia in 2005 to that in 2006?
Make the answer very short. 1. What is the ratio of the Claims (% of GDP) of Sierra Leone in 2005 to that in 2006?
Your response must be concise. 1.03. What is the ratio of the Claims (% of GDP) in Europe(developing only) in 2005 to that in 2007?
Keep it short and to the point. 0.67. What is the ratio of the Claims (% of GDP) of Antigua and Barbuda in 2005 to that in 2007?
Keep it short and to the point. 0.97. What is the ratio of the Claims (% of GDP) of Sierra Leone in 2005 to that in 2007?
Offer a terse response. 0.85. What is the ratio of the Claims (% of GDP) in Europe(developing only) in 2005 to that in 2008?
Provide a short and direct response. 0.57. What is the ratio of the Claims (% of GDP) of Antigua and Barbuda in 2005 to that in 2008?
Provide a succinct answer. 0.95. What is the ratio of the Claims (% of GDP) of Sierra Leone in 2005 to that in 2008?
Provide a short and direct response. 0.66. What is the ratio of the Claims (% of GDP) of Europe(developing only) in 2005 to that in 2009?
Ensure brevity in your answer.  0.54. What is the ratio of the Claims (% of GDP) of Antigua and Barbuda in 2005 to that in 2009?
Your answer should be very brief. 0.84. What is the ratio of the Claims (% of GDP) of Namibia in 2005 to that in 2009?
Offer a terse response. 0.99. What is the ratio of the Claims (% of GDP) in Sierra Leone in 2005 to that in 2009?
Provide a succinct answer. 0.44. What is the ratio of the Claims (% of GDP) of Europe(developing only) in 2005 to that in 2010?
Offer a very short reply. 0.51. What is the ratio of the Claims (% of GDP) of Antigua and Barbuda in 2005 to that in 2010?
Your answer should be compact. 0.79. What is the ratio of the Claims (% of GDP) of Namibia in 2005 to that in 2010?
Make the answer very short. 0.98. What is the ratio of the Claims (% of GDP) of Sierra Leone in 2005 to that in 2010?
Your answer should be very brief. 0.46. What is the ratio of the Claims (% of GDP) of Europe(developing only) in 2005 to that in 2011?
Offer a very short reply. 0.5. What is the ratio of the Claims (% of GDP) of Antigua and Barbuda in 2005 to that in 2011?
Provide a short and direct response. 0.82. What is the ratio of the Claims (% of GDP) of Namibia in 2005 to that in 2011?
Ensure brevity in your answer.  1.01. What is the ratio of the Claims (% of GDP) of Sierra Leone in 2005 to that in 2011?
Your answer should be compact. 0.46. What is the ratio of the Claims (% of GDP) of Europe(developing only) in 2005 to that in 2012?
Give a very brief answer. 0.48. What is the ratio of the Claims (% of GDP) of Antigua and Barbuda in 2005 to that in 2012?
Make the answer very short. 0.9. What is the ratio of the Claims (% of GDP) of Namibia in 2005 to that in 2012?
Keep it short and to the point. 1.03. What is the ratio of the Claims (% of GDP) of Sierra Leone in 2005 to that in 2012?
Provide a succinct answer. 0.55. What is the ratio of the Claims (% of GDP) in Europe(developing only) in 2006 to that in 2007?
Keep it short and to the point. 0.82. What is the ratio of the Claims (% of GDP) in Antigua and Barbuda in 2006 to that in 2007?
Give a very brief answer. 0.99. What is the ratio of the Claims (% of GDP) in Sierra Leone in 2006 to that in 2007?
Give a very brief answer. 0.82. What is the ratio of the Claims (% of GDP) in Europe(developing only) in 2006 to that in 2008?
Offer a terse response. 0.69. What is the ratio of the Claims (% of GDP) in Antigua and Barbuda in 2006 to that in 2008?
Give a very brief answer. 0.97. What is the ratio of the Claims (% of GDP) of Sierra Leone in 2006 to that in 2008?
Provide a succinct answer. 0.63. What is the ratio of the Claims (% of GDP) in Europe(developing only) in 2006 to that in 2009?
Provide a short and direct response. 0.66. What is the ratio of the Claims (% of GDP) in Antigua and Barbuda in 2006 to that in 2009?
Provide a succinct answer. 0.86. What is the ratio of the Claims (% of GDP) of Sierra Leone in 2006 to that in 2009?
Provide a succinct answer. 0.43. What is the ratio of the Claims (% of GDP) in Europe(developing only) in 2006 to that in 2010?
Ensure brevity in your answer.  0.63. What is the ratio of the Claims (% of GDP) in Antigua and Barbuda in 2006 to that in 2010?
Provide a short and direct response. 0.81. What is the ratio of the Claims (% of GDP) of Namibia in 2006 to that in 2010?
Provide a short and direct response. 0.97. What is the ratio of the Claims (% of GDP) in Sierra Leone in 2006 to that in 2010?
Give a very brief answer. 0.44. What is the ratio of the Claims (% of GDP) of Europe(developing only) in 2006 to that in 2011?
Your answer should be very brief. 0.61. What is the ratio of the Claims (% of GDP) in Antigua and Barbuda in 2006 to that in 2011?
Your answer should be compact. 0.84. What is the ratio of the Claims (% of GDP) in Namibia in 2006 to that in 2011?
Your answer should be very brief. 1.01. What is the ratio of the Claims (% of GDP) in Sierra Leone in 2006 to that in 2011?
Make the answer very short. 0.45. What is the ratio of the Claims (% of GDP) of Europe(developing only) in 2006 to that in 2012?
Ensure brevity in your answer.  0.59. What is the ratio of the Claims (% of GDP) in Antigua and Barbuda in 2006 to that in 2012?
Provide a short and direct response. 0.92. What is the ratio of the Claims (% of GDP) of Namibia in 2006 to that in 2012?
Give a very brief answer. 1.03. What is the ratio of the Claims (% of GDP) in Sierra Leone in 2006 to that in 2012?
Ensure brevity in your answer.  0.53. What is the ratio of the Claims (% of GDP) of Europe(developing only) in 2007 to that in 2008?
Provide a succinct answer. 0.85. What is the ratio of the Claims (% of GDP) in Antigua and Barbuda in 2007 to that in 2008?
Offer a very short reply. 0.99. What is the ratio of the Claims (% of GDP) of Sierra Leone in 2007 to that in 2008?
Ensure brevity in your answer.  0.77. What is the ratio of the Claims (% of GDP) of Europe(developing only) in 2007 to that in 2009?
Provide a succinct answer. 0.81. What is the ratio of the Claims (% of GDP) of Antigua and Barbuda in 2007 to that in 2009?
Give a very brief answer. 0.87. What is the ratio of the Claims (% of GDP) of Namibia in 2007 to that in 2009?
Your answer should be very brief. 0.99. What is the ratio of the Claims (% of GDP) in Sierra Leone in 2007 to that in 2009?
Provide a short and direct response. 0.52. What is the ratio of the Claims (% of GDP) of Europe(developing only) in 2007 to that in 2010?
Offer a terse response. 0.77. What is the ratio of the Claims (% of GDP) of Antigua and Barbuda in 2007 to that in 2010?
Ensure brevity in your answer.  0.82. What is the ratio of the Claims (% of GDP) in Namibia in 2007 to that in 2010?
Your answer should be very brief. 0.98. What is the ratio of the Claims (% of GDP) of Sierra Leone in 2007 to that in 2010?
Ensure brevity in your answer.  0.54. What is the ratio of the Claims (% of GDP) of Europe(developing only) in 2007 to that in 2011?
Your response must be concise. 0.75. What is the ratio of the Claims (% of GDP) in Antigua and Barbuda in 2007 to that in 2011?
Keep it short and to the point. 0.85. What is the ratio of the Claims (% of GDP) of Namibia in 2007 to that in 2011?
Offer a very short reply. 1.01. What is the ratio of the Claims (% of GDP) of Sierra Leone in 2007 to that in 2011?
Your answer should be compact. 0.54. What is the ratio of the Claims (% of GDP) in Europe(developing only) in 2007 to that in 2012?
Ensure brevity in your answer.  0.72. What is the ratio of the Claims (% of GDP) of Antigua and Barbuda in 2007 to that in 2012?
Your answer should be very brief. 0.93. What is the ratio of the Claims (% of GDP) of Namibia in 2007 to that in 2012?
Offer a terse response. 1.03. What is the ratio of the Claims (% of GDP) in Sierra Leone in 2007 to that in 2012?
Your answer should be very brief. 0.64. What is the ratio of the Claims (% of GDP) in Europe(developing only) in 2008 to that in 2009?
Provide a succinct answer. 0.95. What is the ratio of the Claims (% of GDP) of Antigua and Barbuda in 2008 to that in 2009?
Your answer should be very brief. 0.88. What is the ratio of the Claims (% of GDP) of Namibia in 2008 to that in 2009?
Offer a very short reply. 0.99. What is the ratio of the Claims (% of GDP) of Sierra Leone in 2008 to that in 2009?
Provide a succinct answer. 0.67. What is the ratio of the Claims (% of GDP) of Europe(developing only) in 2008 to that in 2010?
Give a very brief answer. 0.91. What is the ratio of the Claims (% of GDP) in Antigua and Barbuda in 2008 to that in 2010?
Offer a very short reply. 0.83. What is the ratio of the Claims (% of GDP) in Namibia in 2008 to that in 2010?
Provide a succinct answer. 0.97. What is the ratio of the Claims (% of GDP) of Sierra Leone in 2008 to that in 2010?
Give a very brief answer. 0.7. What is the ratio of the Claims (% of GDP) in Europe(developing only) in 2008 to that in 2011?
Your answer should be compact. 0.88. What is the ratio of the Claims (% of GDP) of Antigua and Barbuda in 2008 to that in 2011?
Provide a short and direct response. 0.86. What is the ratio of the Claims (% of GDP) of Namibia in 2008 to that in 2011?
Your answer should be compact. 1. What is the ratio of the Claims (% of GDP) of Sierra Leone in 2008 to that in 2011?
Give a very brief answer. 0.7. What is the ratio of the Claims (% of GDP) of Europe(developing only) in 2008 to that in 2012?
Provide a succinct answer. 0.85. What is the ratio of the Claims (% of GDP) of Antigua and Barbuda in 2008 to that in 2012?
Offer a terse response. 0.94. What is the ratio of the Claims (% of GDP) in Namibia in 2008 to that in 2012?
Provide a succinct answer. 1.02. What is the ratio of the Claims (% of GDP) of Sierra Leone in 2008 to that in 2012?
Offer a very short reply. 0.84. What is the ratio of the Claims (% of GDP) in Europe(developing only) in 2009 to that in 2010?
Offer a terse response. 0.95. What is the ratio of the Claims (% of GDP) in Antigua and Barbuda in 2009 to that in 2010?
Your answer should be very brief. 0.94. What is the ratio of the Claims (% of GDP) of Namibia in 2009 to that in 2010?
Your answer should be compact. 0.98. What is the ratio of the Claims (% of GDP) of Sierra Leone in 2009 to that in 2010?
Provide a succinct answer. 1.04. What is the ratio of the Claims (% of GDP) of Europe(developing only) in 2009 to that in 2011?
Provide a short and direct response. 0.93. What is the ratio of the Claims (% of GDP) in Antigua and Barbuda in 2009 to that in 2011?
Your response must be concise. 0.97. What is the ratio of the Claims (% of GDP) in Namibia in 2009 to that in 2011?
Offer a very short reply. 1.01. What is the ratio of the Claims (% of GDP) in Sierra Leone in 2009 to that in 2011?
Your response must be concise. 1.05. What is the ratio of the Claims (% of GDP) in Europe(developing only) in 2009 to that in 2012?
Keep it short and to the point. 0.89. What is the ratio of the Claims (% of GDP) of Antigua and Barbuda in 2009 to that in 2012?
Your answer should be very brief. 1.07. What is the ratio of the Claims (% of GDP) in Namibia in 2009 to that in 2012?
Give a very brief answer. 1.04. What is the ratio of the Claims (% of GDP) of Sierra Leone in 2009 to that in 2012?
Provide a short and direct response. 1.25. What is the ratio of the Claims (% of GDP) in Europe(developing only) in 2010 to that in 2011?
Provide a short and direct response. 0.97. What is the ratio of the Claims (% of GDP) in Antigua and Barbuda in 2010 to that in 2011?
Make the answer very short. 1.04. What is the ratio of the Claims (% of GDP) of Namibia in 2010 to that in 2011?
Your answer should be compact. 1.03. What is the ratio of the Claims (% of GDP) in Sierra Leone in 2010 to that in 2011?
Provide a succinct answer. 1.01. What is the ratio of the Claims (% of GDP) in Europe(developing only) in 2010 to that in 2012?
Make the answer very short. 0.93. What is the ratio of the Claims (% of GDP) in Antigua and Barbuda in 2010 to that in 2012?
Provide a succinct answer. 1.14. What is the ratio of the Claims (% of GDP) of Namibia in 2010 to that in 2012?
Offer a terse response. 1.06. What is the ratio of the Claims (% of GDP) of Sierra Leone in 2010 to that in 2012?
Offer a terse response. 1.2. What is the ratio of the Claims (% of GDP) of Europe(developing only) in 2011 to that in 2012?
Provide a short and direct response. 0.96. What is the ratio of the Claims (% of GDP) in Antigua and Barbuda in 2011 to that in 2012?
Give a very brief answer. 1.1. What is the ratio of the Claims (% of GDP) of Namibia in 2011 to that in 2012?
Your answer should be compact. 1.02. What is the ratio of the Claims (% of GDP) of Sierra Leone in 2011 to that in 2012?
Give a very brief answer. 1.19. What is the difference between the highest and the second highest Claims (% of GDP) in Europe(developing only)?
Your response must be concise. 2.1. What is the difference between the highest and the second highest Claims (% of GDP) in Antigua and Barbuda?
Offer a very short reply. 2.99. What is the difference between the highest and the second highest Claims (% of GDP) in Namibia?
Provide a short and direct response. 1. What is the difference between the highest and the second highest Claims (% of GDP) of Sierra Leone?
Give a very brief answer. 0.34. What is the difference between the highest and the lowest Claims (% of GDP) in Europe(developing only)?
Offer a terse response. 28.02. What is the difference between the highest and the lowest Claims (% of GDP) of Antigua and Barbuda?
Ensure brevity in your answer.  17.91. What is the difference between the highest and the lowest Claims (% of GDP) in Namibia?
Make the answer very short. 2.86. What is the difference between the highest and the lowest Claims (% of GDP) in Sierra Leone?
Provide a short and direct response. 5.16. 